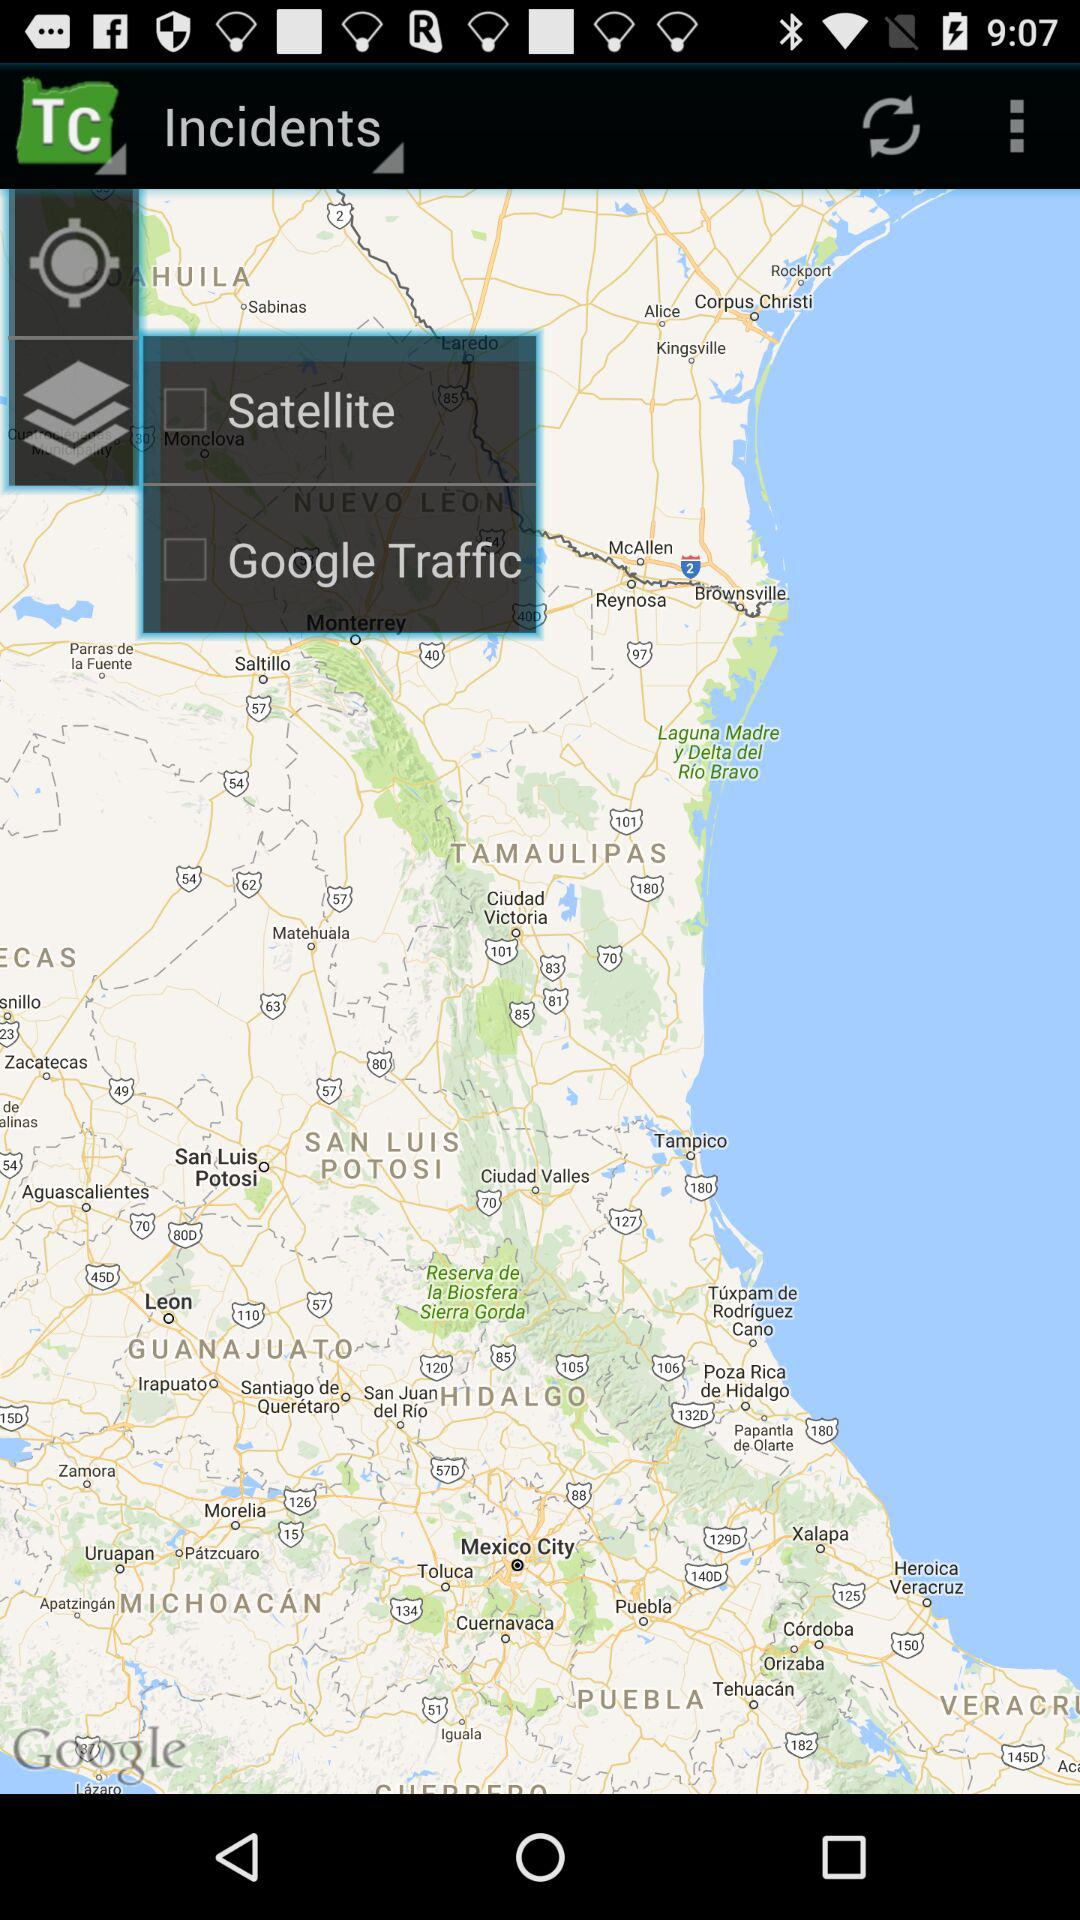What is the status of the "Satellite"? The status of the "Satellite" is off. 